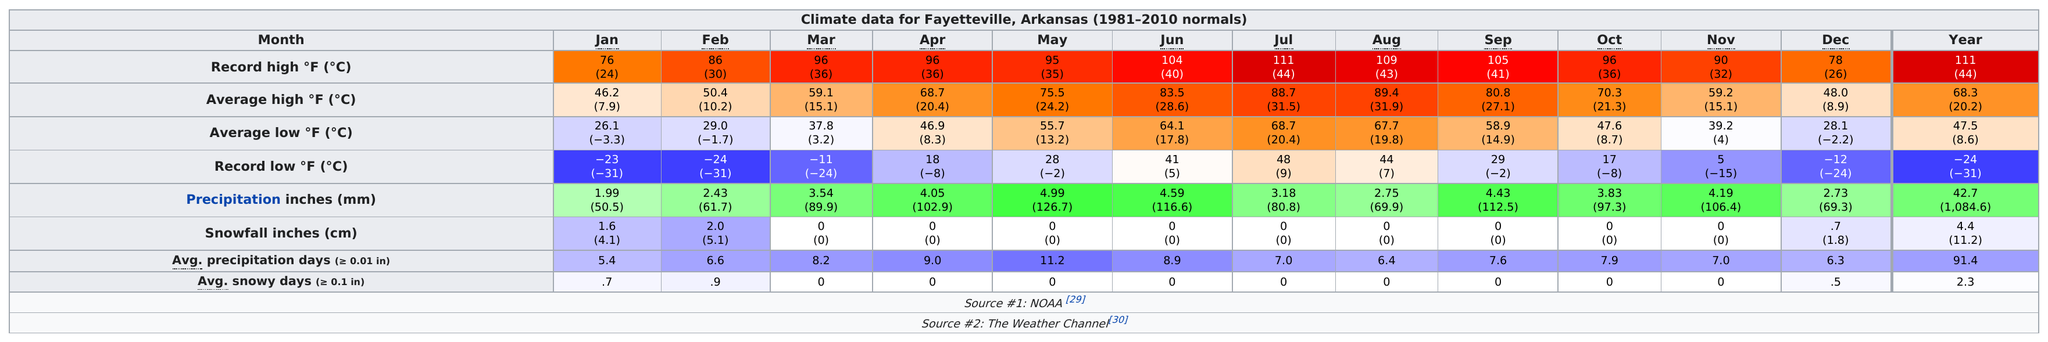Give some essential details in this illustration. The average high temperature for Fayetteville, Arkansas in June is 83.5 degrees. July was the month that set the record high in temperature. August was the month with the highest average temperature. The average high temperature in Fayetteville, Arkansas during March is 59.1 degrees. 